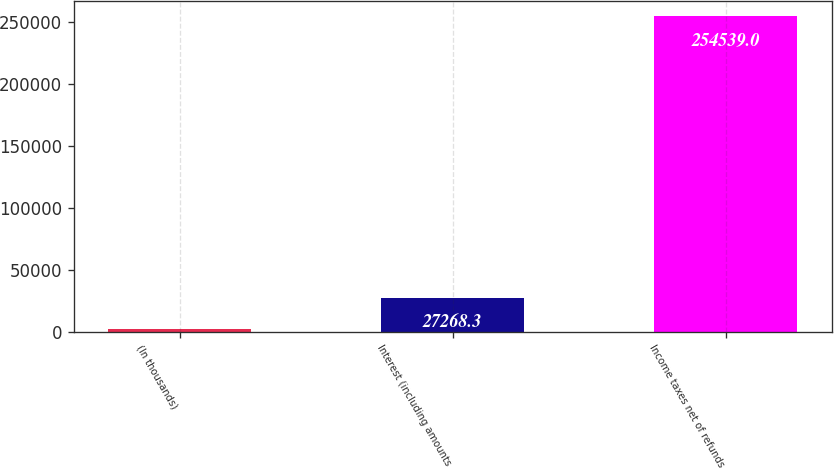Convert chart. <chart><loc_0><loc_0><loc_500><loc_500><bar_chart><fcel>(In thousands)<fcel>Interest (including amounts<fcel>Income taxes net of refunds<nl><fcel>2016<fcel>27268.3<fcel>254539<nl></chart> 